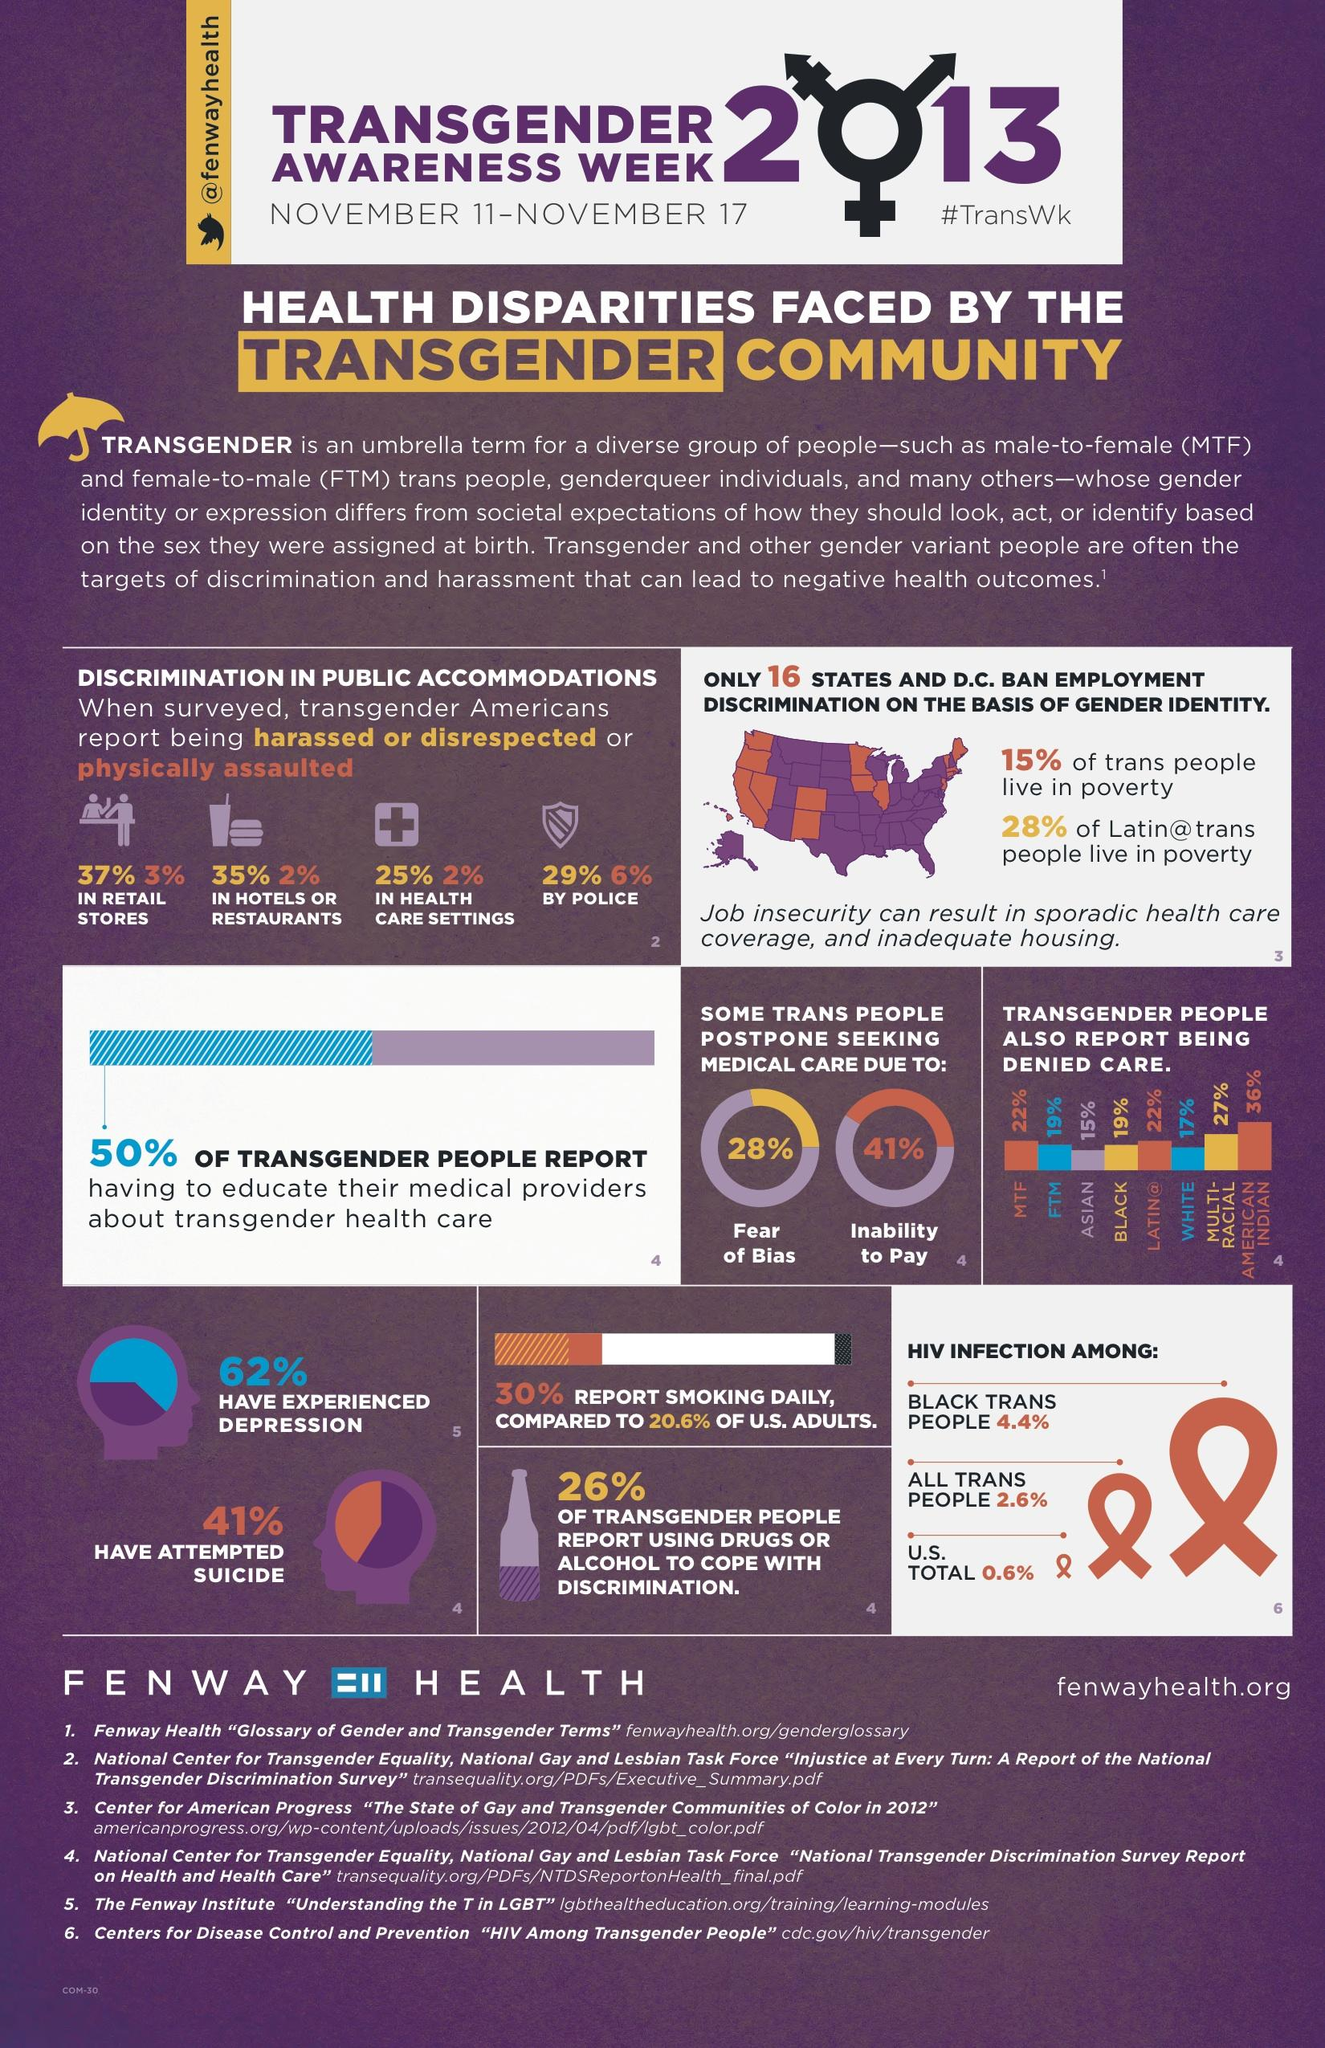Highlight a few significant elements in this photo. A recent survey has revealed that approximately 3% of retail store workers have been physically assaulted while on the job. According to a study on daily smoking among US adults and transgenders, there is a 9.4% difference in smoking rates between the two groups. According to a recent study, approximately 6% of people have been physically assaulted by police. According to the survey, 41% of respondents reported postponing medical care due to their inability to pay for it. 